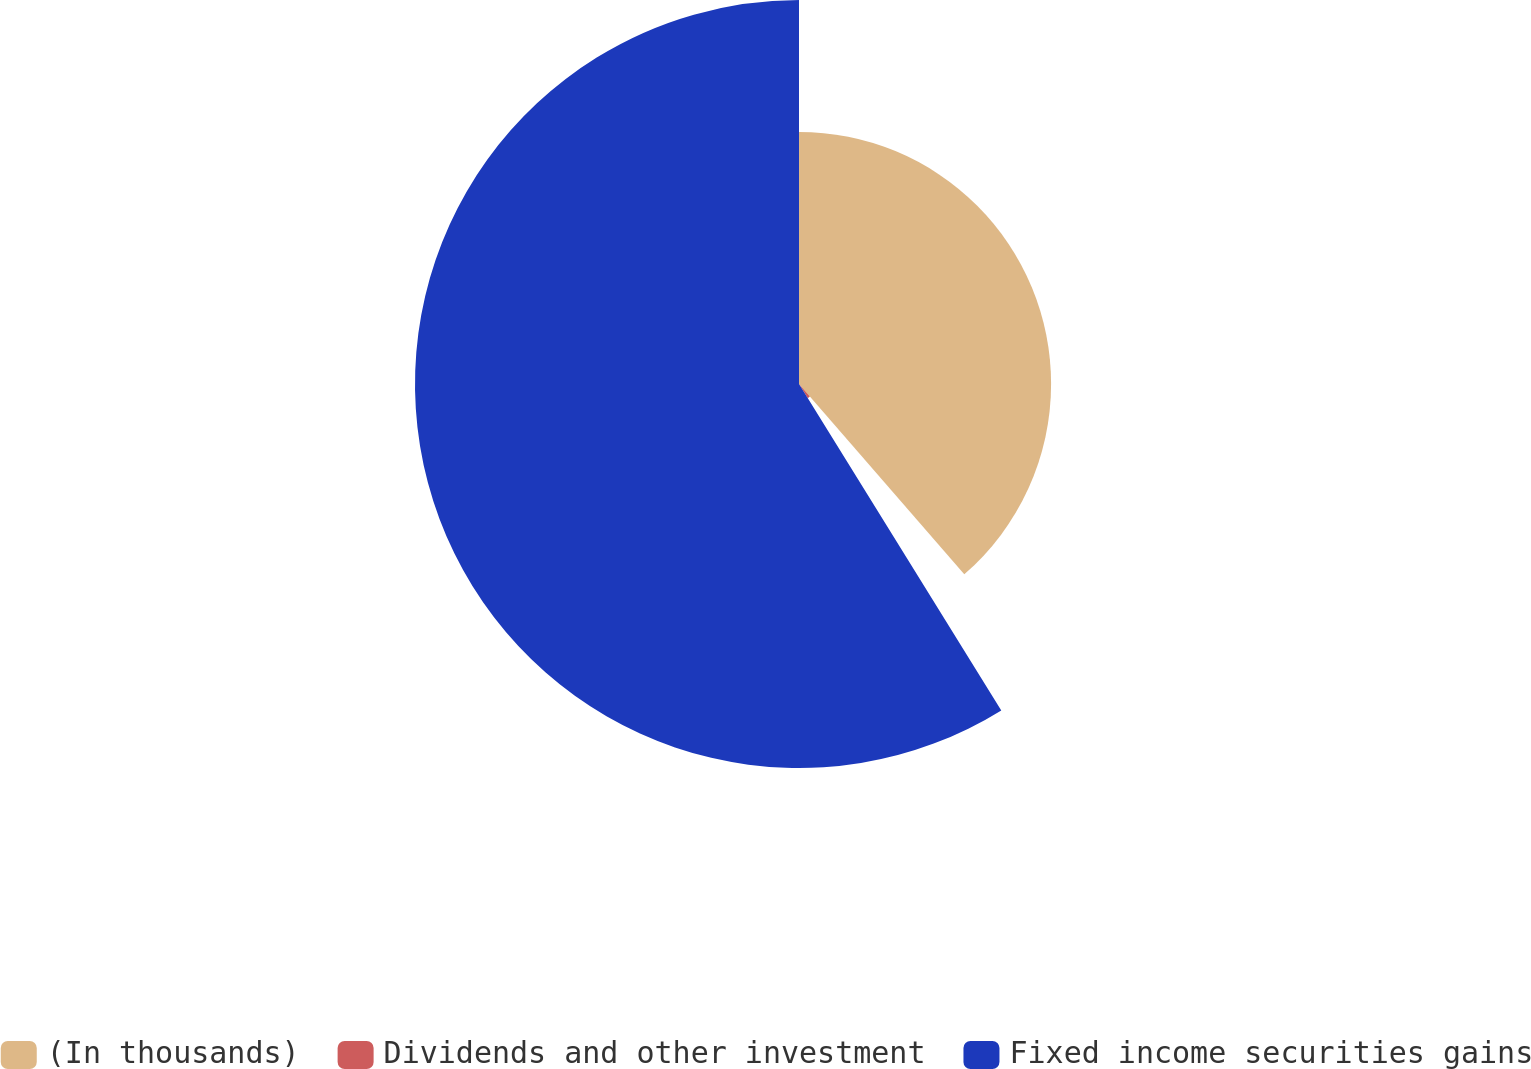Convert chart to OTSL. <chart><loc_0><loc_0><loc_500><loc_500><pie_chart><fcel>(In thousands)<fcel>Dividends and other investment<fcel>Fixed income securities gains<nl><fcel>38.62%<fcel>2.55%<fcel>58.83%<nl></chart> 